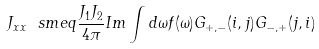<formula> <loc_0><loc_0><loc_500><loc_500>J _ { x x } \ s m e q \frac { J _ { 1 } J _ { 2 } } { 4 \pi } I m \int d \omega f ( \omega ) G _ { + , - } ( i , j ) G _ { - , + } ( j , i )</formula> 